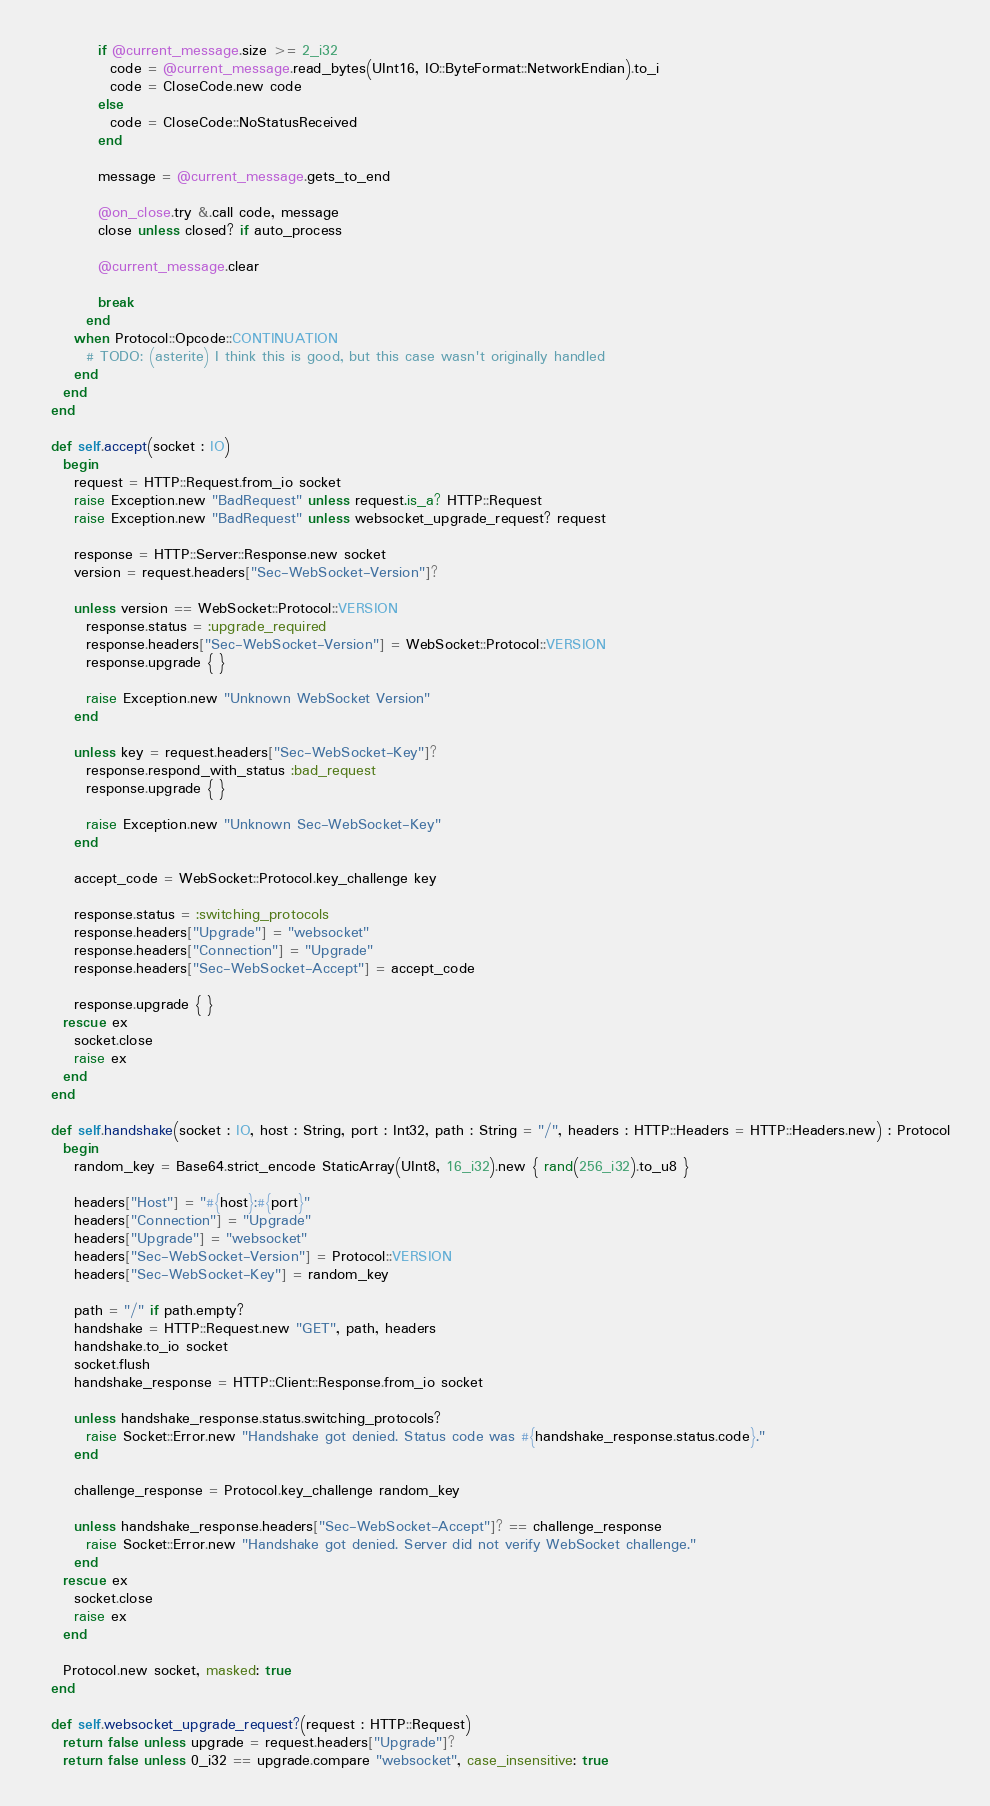<code> <loc_0><loc_0><loc_500><loc_500><_Crystal_>          if @current_message.size >= 2_i32
            code = @current_message.read_bytes(UInt16, IO::ByteFormat::NetworkEndian).to_i
            code = CloseCode.new code
          else
            code = CloseCode::NoStatusReceived
          end

          message = @current_message.gets_to_end

          @on_close.try &.call code, message
          close unless closed? if auto_process

          @current_message.clear

          break
        end
      when Protocol::Opcode::CONTINUATION
        # TODO: (asterite) I think this is good, but this case wasn't originally handled
      end
    end
  end

  def self.accept(socket : IO)
    begin
      request = HTTP::Request.from_io socket
      raise Exception.new "BadRequest" unless request.is_a? HTTP::Request
      raise Exception.new "BadRequest" unless websocket_upgrade_request? request

      response = HTTP::Server::Response.new socket
      version = request.headers["Sec-WebSocket-Version"]?

      unless version == WebSocket::Protocol::VERSION
        response.status = :upgrade_required
        response.headers["Sec-WebSocket-Version"] = WebSocket::Protocol::VERSION
        response.upgrade { }

        raise Exception.new "Unknown WebSocket Version"
      end

      unless key = request.headers["Sec-WebSocket-Key"]?
        response.respond_with_status :bad_request
        response.upgrade { }

        raise Exception.new "Unknown Sec-WebSocket-Key"
      end

      accept_code = WebSocket::Protocol.key_challenge key

      response.status = :switching_protocols
      response.headers["Upgrade"] = "websocket"
      response.headers["Connection"] = "Upgrade"
      response.headers["Sec-WebSocket-Accept"] = accept_code

      response.upgrade { }
    rescue ex
      socket.close
      raise ex
    end
  end

  def self.handshake(socket : IO, host : String, port : Int32, path : String = "/", headers : HTTP::Headers = HTTP::Headers.new) : Protocol
    begin
      random_key = Base64.strict_encode StaticArray(UInt8, 16_i32).new { rand(256_i32).to_u8 }

      headers["Host"] = "#{host}:#{port}"
      headers["Connection"] = "Upgrade"
      headers["Upgrade"] = "websocket"
      headers["Sec-WebSocket-Version"] = Protocol::VERSION
      headers["Sec-WebSocket-Key"] = random_key

      path = "/" if path.empty?
      handshake = HTTP::Request.new "GET", path, headers
      handshake.to_io socket
      socket.flush
      handshake_response = HTTP::Client::Response.from_io socket

      unless handshake_response.status.switching_protocols?
        raise Socket::Error.new "Handshake got denied. Status code was #{handshake_response.status.code}."
      end

      challenge_response = Protocol.key_challenge random_key

      unless handshake_response.headers["Sec-WebSocket-Accept"]? == challenge_response
        raise Socket::Error.new "Handshake got denied. Server did not verify WebSocket challenge."
      end
    rescue ex
      socket.close
      raise ex
    end

    Protocol.new socket, masked: true
  end

  def self.websocket_upgrade_request?(request : HTTP::Request)
    return false unless upgrade = request.headers["Upgrade"]?
    return false unless 0_i32 == upgrade.compare "websocket", case_insensitive: true
</code> 